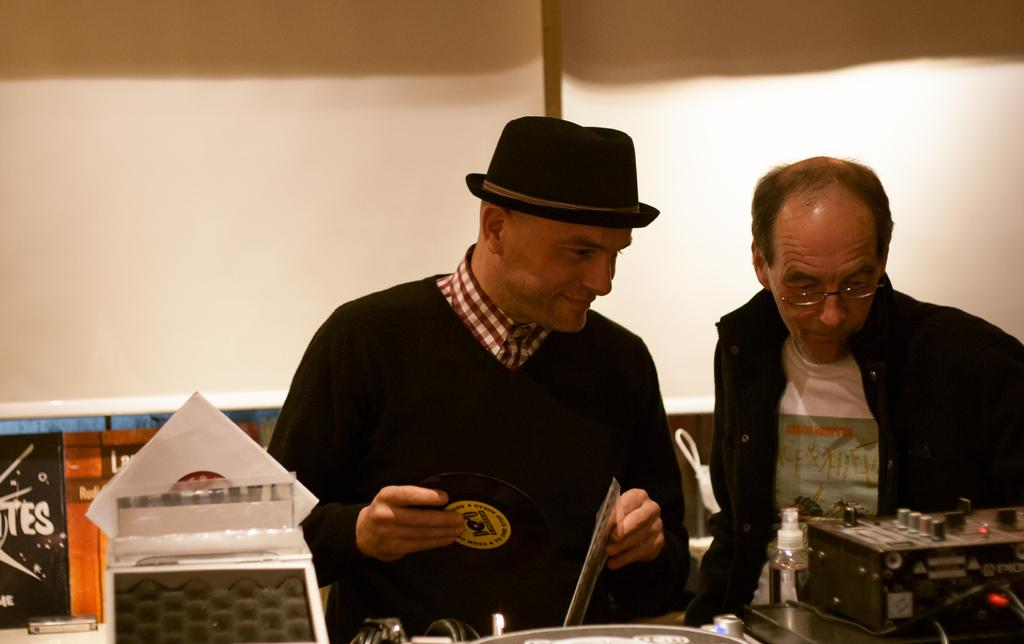How many people are in the image? There are two men in the image. What is in front of the men? There is equipment in front of the men. What is the first person holding in his hand? The first person is holding an object in his hand. What can be seen in the background of the image? There is a wall in the background of the image. What type of hope is the second man expressing in the image? There is no indication of hope or any emotions in the image; it only shows two men and equipment in front of them. 